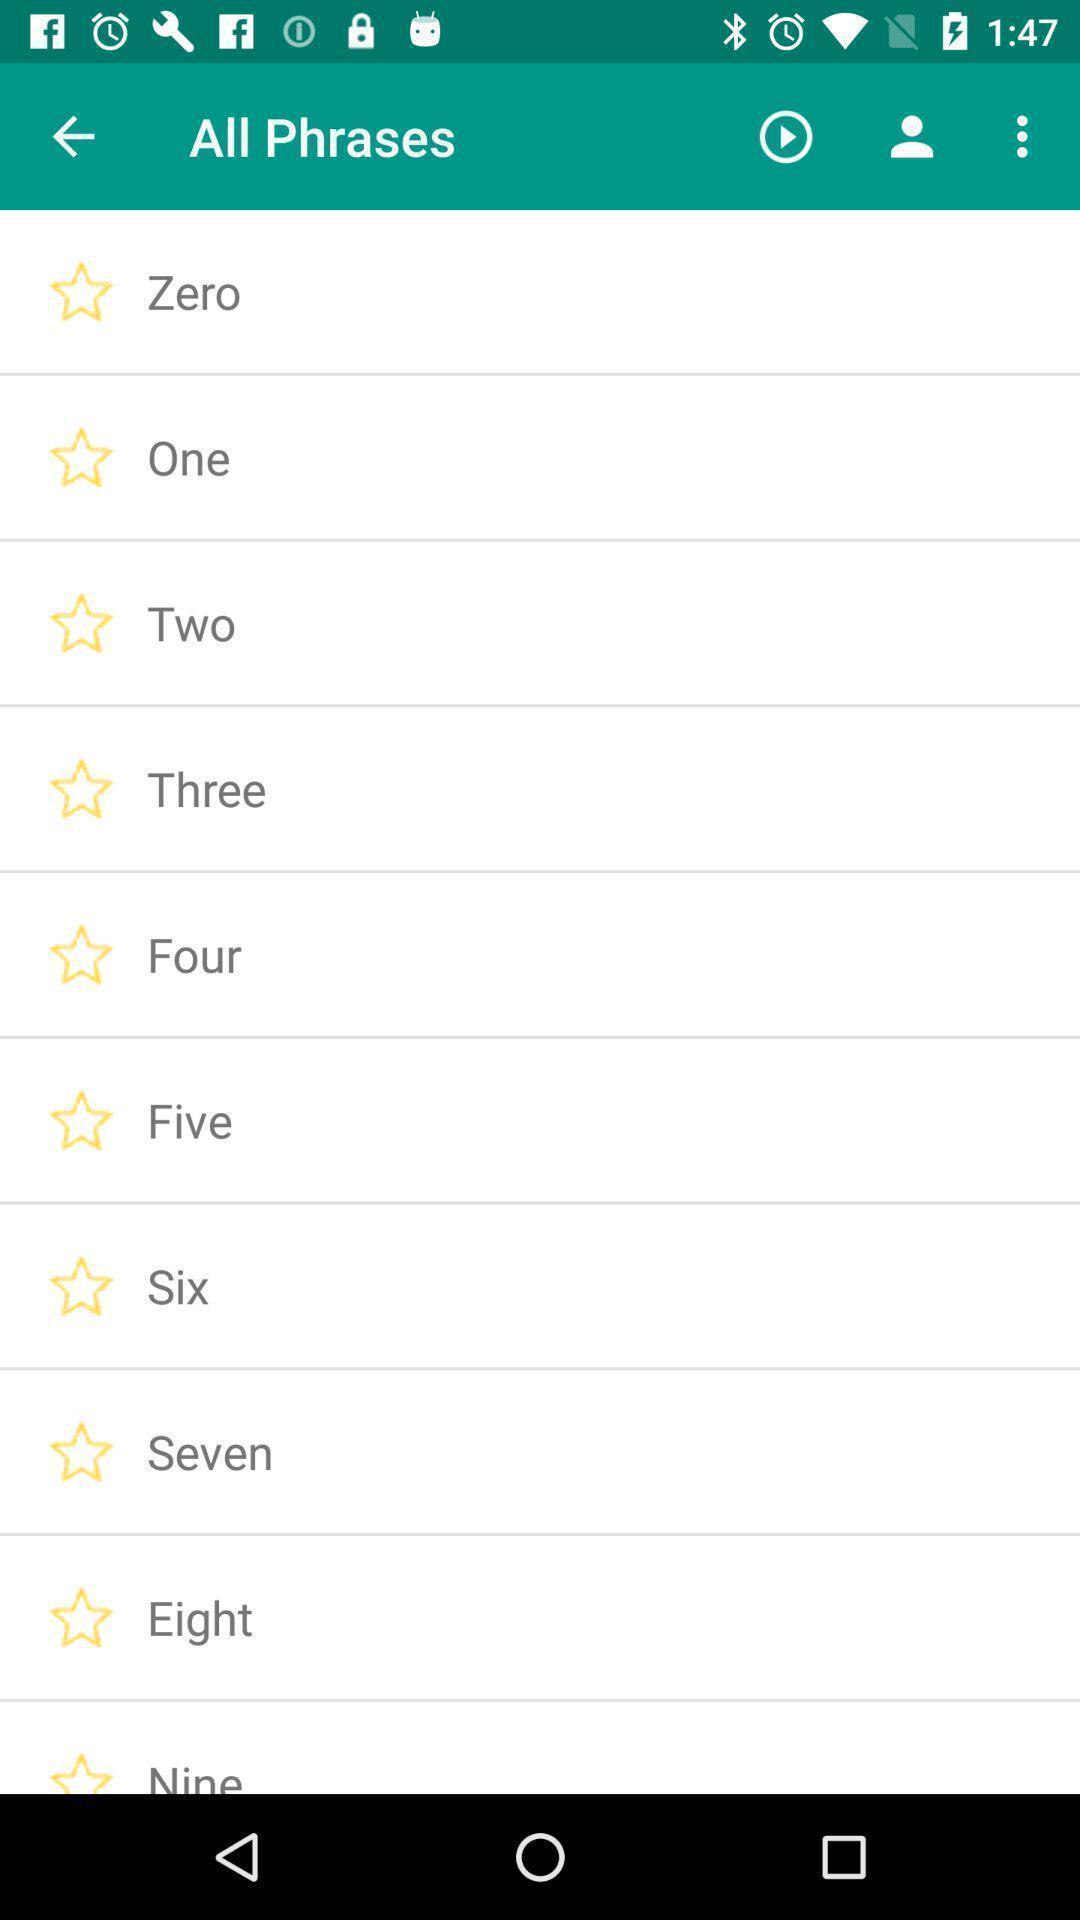Provide a textual representation of this image. Screen displaying list of numbers. 